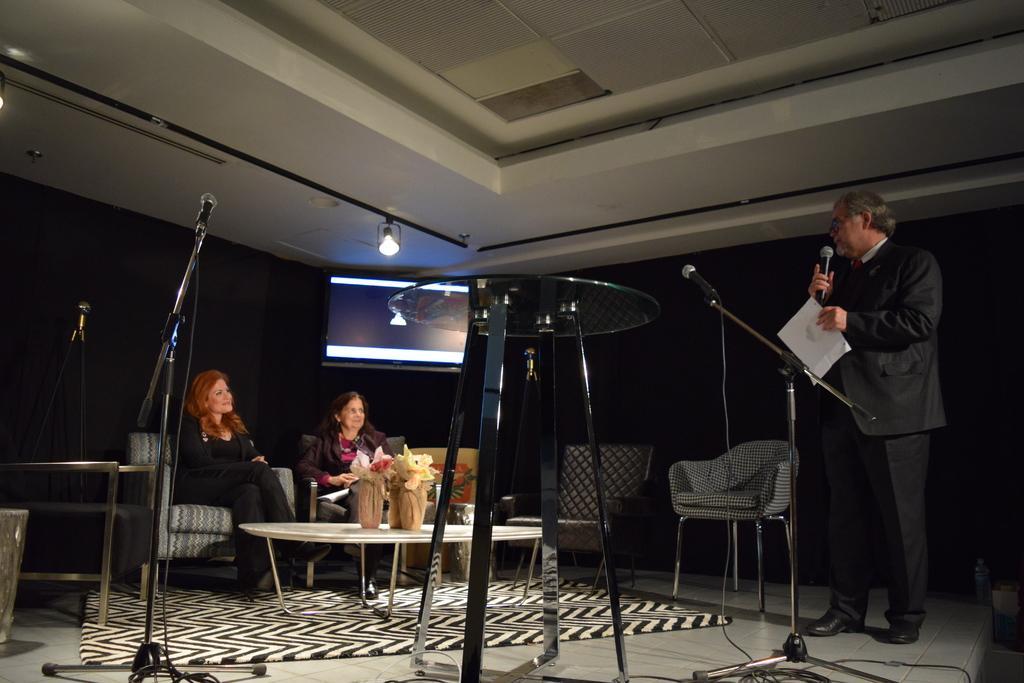In one or two sentences, can you explain what this image depicts? In this image we can see a person holding a mic and paper. Also there are chairs. Two are sitting. There is a table with some objects. There are mics with stands. Also there are other tables. In the back there is a screen. On the ceiling there is light. On the floor there is a carpet. 